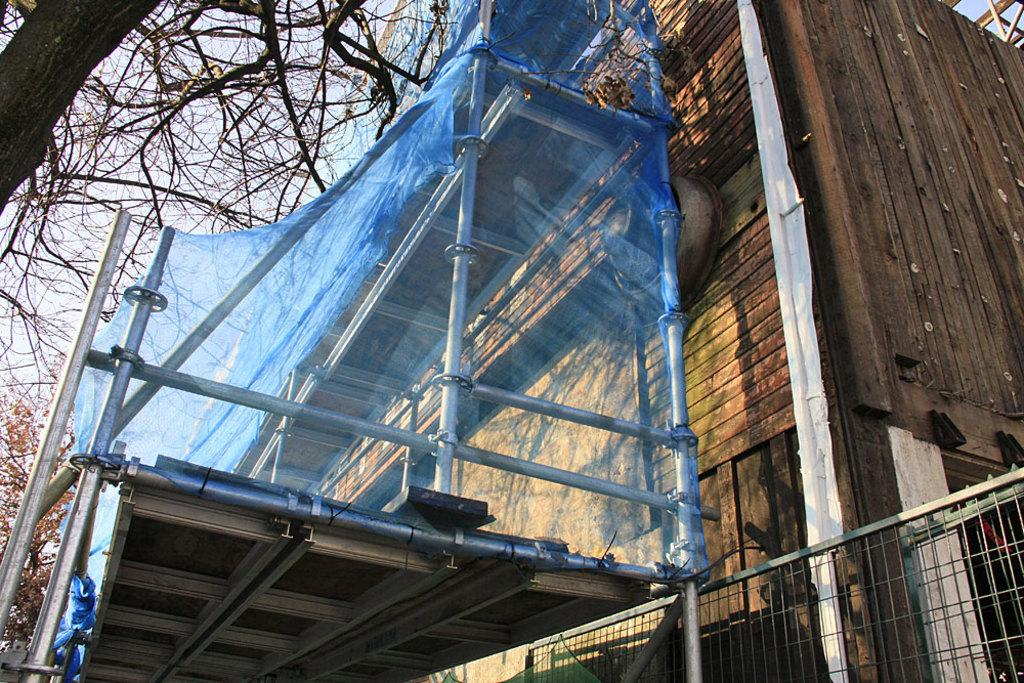What type of structure is present in the image? There is a building in the image. What is located near the building? There is a fence in the image. What type of natural elements can be seen in the image? There are trees in the image. What else can be seen in the image besides the building, fence, and trees? There are other objects in the image. What is visible in the background of the image? The sky is visible in the background of the image. How many bones are visible in the image? There are no bones present in the image. 